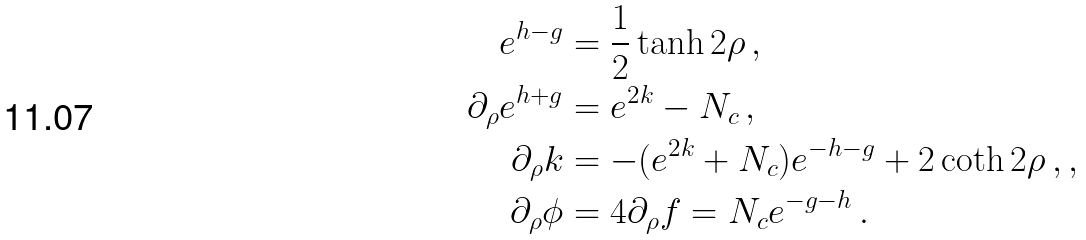Convert formula to latex. <formula><loc_0><loc_0><loc_500><loc_500>e ^ { h - g } & = \frac { 1 } { 2 } \tanh { 2 \rho } \, , \\ \partial _ { \rho } e ^ { h + g } & = e ^ { 2 k } - N _ { c } \, , \\ \partial _ { \rho } k & = - ( e ^ { 2 k } + N _ { c } ) e ^ { - h - g } + 2 \coth 2 \rho \, , , \\ \partial _ { \rho } \phi & = 4 \partial _ { \rho } f = N _ { c } e ^ { - g - h } \, .</formula> 